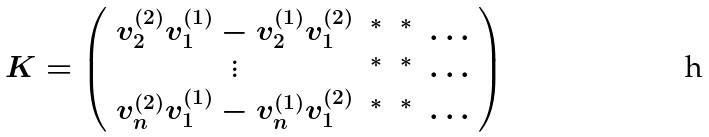<formula> <loc_0><loc_0><loc_500><loc_500>K = \left ( \begin{array} { c c c c } v ^ { ( 2 ) } _ { 2 } v ^ { ( 1 ) } _ { 1 } - v ^ { ( 1 ) } _ { 2 } v ^ { ( 2 ) } _ { 1 } & ^ { * } & ^ { * } & \dots \\ \vdots & ^ { * } & ^ { * } & \dots \\ v ^ { ( 2 ) } _ { n } v ^ { ( 1 ) } _ { 1 } - v ^ { ( 1 ) } _ { n } v ^ { ( 2 ) } _ { 1 } & ^ { * } & ^ { * } & \dots \\ \end{array} \right )</formula> 